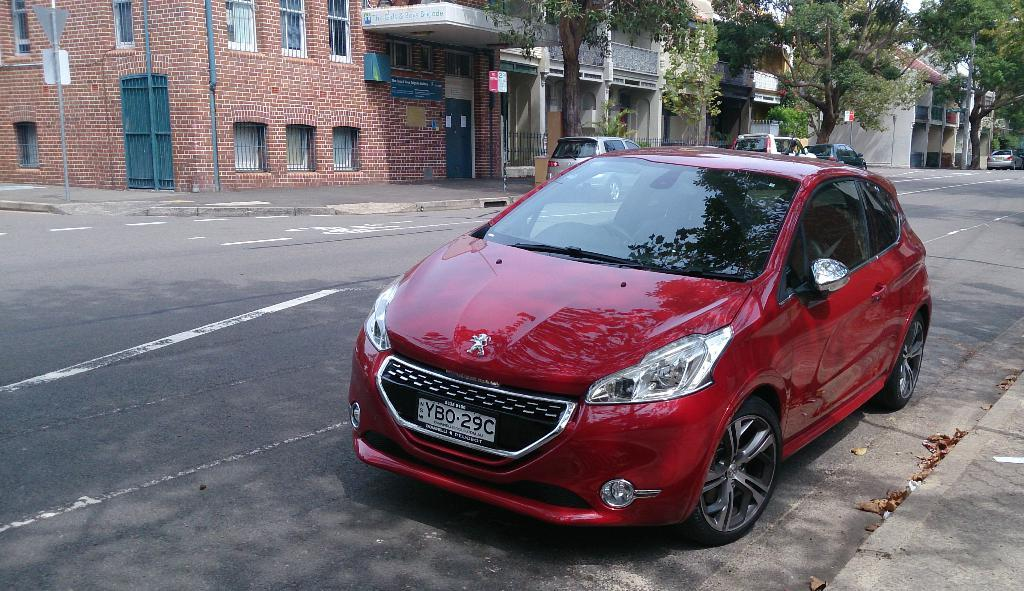What can be seen on the road in the image? There are vehicles on the road in the image. What type of natural elements are visible in the background? There are trees in the background of the image. What type of man-made structures can be seen in the background? There are buildings in the background of the image. What type of vertical structures are present in the background? There are poles in the background of the image. What type of flat, sign-like objects are present in the background? There are boards in the background of the image. Can you describe any other objects visible in the background? There are other unspecified objects in the background of the image. What type of trail can be seen in the image? There is no trail visible in the image. What sound can be heard coming from the vehicles in the image? The image is silent, so no sounds can be heard. 